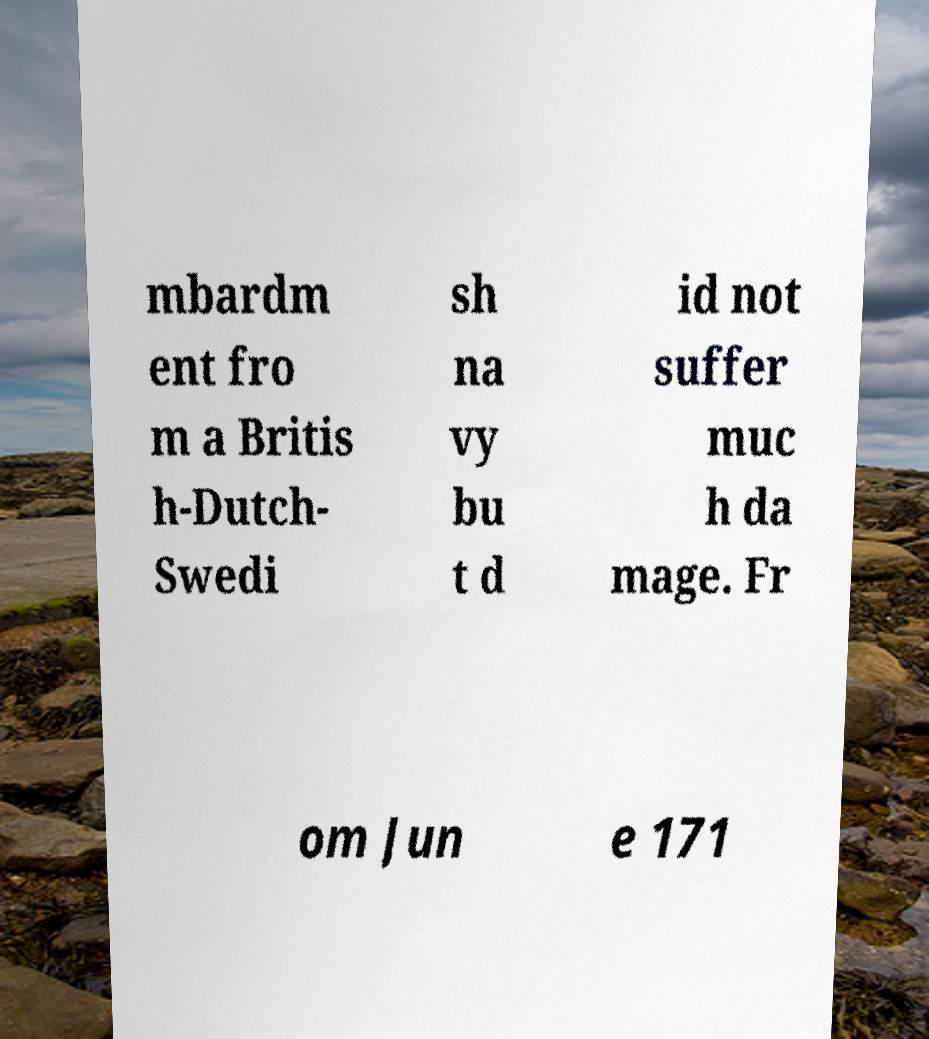Can you read and provide the text displayed in the image?This photo seems to have some interesting text. Can you extract and type it out for me? mbardm ent fro m a Britis h-Dutch- Swedi sh na vy bu t d id not suffer muc h da mage. Fr om Jun e 171 